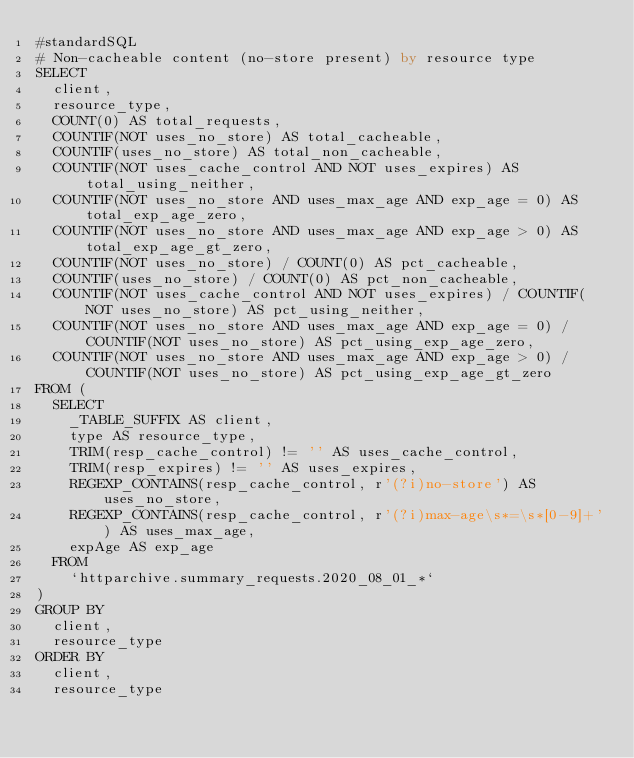Convert code to text. <code><loc_0><loc_0><loc_500><loc_500><_SQL_>#standardSQL
# Non-cacheable content (no-store present) by resource type
SELECT
  client,
  resource_type,
  COUNT(0) AS total_requests,
  COUNTIF(NOT uses_no_store) AS total_cacheable,
  COUNTIF(uses_no_store) AS total_non_cacheable,
  COUNTIF(NOT uses_cache_control AND NOT uses_expires) AS total_using_neither,
  COUNTIF(NOT uses_no_store AND uses_max_age AND exp_age = 0) AS total_exp_age_zero,
  COUNTIF(NOT uses_no_store AND uses_max_age AND exp_age > 0) AS total_exp_age_gt_zero,
  COUNTIF(NOT uses_no_store) / COUNT(0) AS pct_cacheable,
  COUNTIF(uses_no_store) / COUNT(0) AS pct_non_cacheable,
  COUNTIF(NOT uses_cache_control AND NOT uses_expires) / COUNTIF(NOT uses_no_store) AS pct_using_neither,
  COUNTIF(NOT uses_no_store AND uses_max_age AND exp_age = 0) / COUNTIF(NOT uses_no_store) AS pct_using_exp_age_zero,
  COUNTIF(NOT uses_no_store AND uses_max_age AND exp_age > 0) / COUNTIF(NOT uses_no_store) AS pct_using_exp_age_gt_zero
FROM (
  SELECT
    _TABLE_SUFFIX AS client,
    type AS resource_type,
    TRIM(resp_cache_control) != '' AS uses_cache_control,
    TRIM(resp_expires) != '' AS uses_expires,
    REGEXP_CONTAINS(resp_cache_control, r'(?i)no-store') AS uses_no_store,
    REGEXP_CONTAINS(resp_cache_control, r'(?i)max-age\s*=\s*[0-9]+') AS uses_max_age,
    expAge AS exp_age
  FROM
    `httparchive.summary_requests.2020_08_01_*`
)
GROUP BY
  client,
  resource_type
ORDER BY
  client,
  resource_type
</code> 